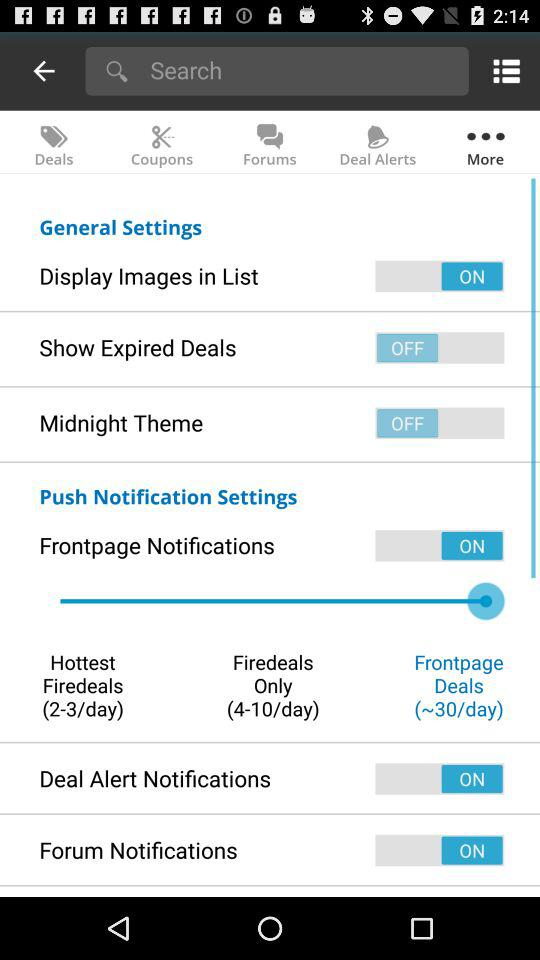Which "General Settings" are switched on? The setting which is switched on is "Display Images in List". 